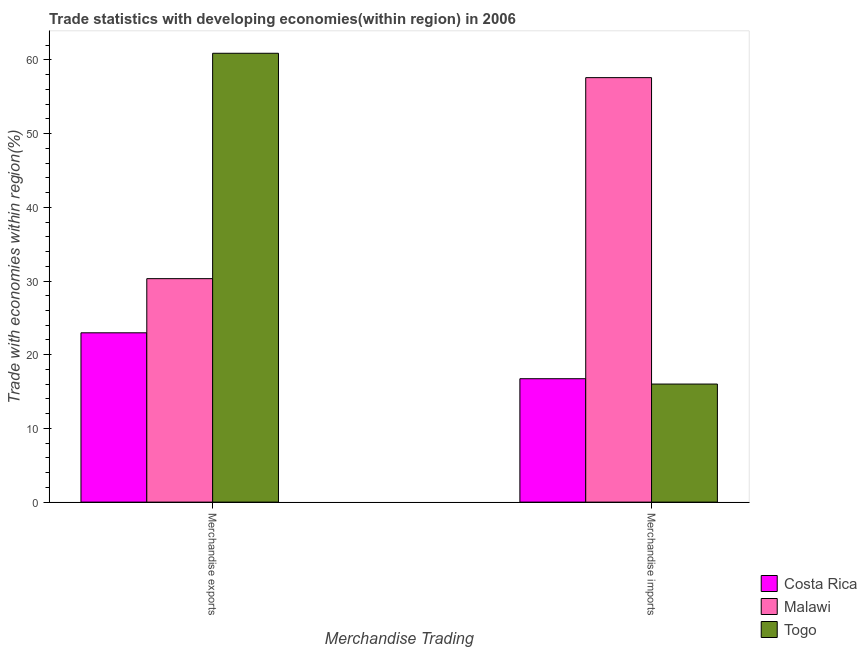How many different coloured bars are there?
Provide a succinct answer. 3. Are the number of bars on each tick of the X-axis equal?
Provide a succinct answer. Yes. What is the label of the 1st group of bars from the left?
Offer a very short reply. Merchandise exports. What is the merchandise imports in Malawi?
Your response must be concise. 57.6. Across all countries, what is the maximum merchandise imports?
Your response must be concise. 57.6. Across all countries, what is the minimum merchandise exports?
Provide a short and direct response. 22.98. In which country was the merchandise imports maximum?
Your response must be concise. Malawi. What is the total merchandise exports in the graph?
Offer a very short reply. 114.21. What is the difference between the merchandise imports in Togo and that in Malawi?
Make the answer very short. -41.58. What is the difference between the merchandise exports in Togo and the merchandise imports in Malawi?
Ensure brevity in your answer.  3.31. What is the average merchandise exports per country?
Your answer should be compact. 38.07. What is the difference between the merchandise exports and merchandise imports in Togo?
Give a very brief answer. 44.89. In how many countries, is the merchandise imports greater than 52 %?
Your answer should be very brief. 1. What is the ratio of the merchandise exports in Malawi to that in Costa Rica?
Provide a short and direct response. 1.32. In how many countries, is the merchandise imports greater than the average merchandise imports taken over all countries?
Keep it short and to the point. 1. What does the 2nd bar from the left in Merchandise imports represents?
Provide a succinct answer. Malawi. What does the 3rd bar from the right in Merchandise exports represents?
Give a very brief answer. Costa Rica. How many bars are there?
Make the answer very short. 6. Are all the bars in the graph horizontal?
Your answer should be very brief. No. How many countries are there in the graph?
Your answer should be compact. 3. What is the difference between two consecutive major ticks on the Y-axis?
Provide a succinct answer. 10. Where does the legend appear in the graph?
Ensure brevity in your answer.  Bottom right. How many legend labels are there?
Your answer should be very brief. 3. How are the legend labels stacked?
Your answer should be compact. Vertical. What is the title of the graph?
Offer a terse response. Trade statistics with developing economies(within region) in 2006. What is the label or title of the X-axis?
Offer a terse response. Merchandise Trading. What is the label or title of the Y-axis?
Provide a succinct answer. Trade with economies within region(%). What is the Trade with economies within region(%) of Costa Rica in Merchandise exports?
Offer a very short reply. 22.98. What is the Trade with economies within region(%) in Malawi in Merchandise exports?
Your response must be concise. 30.32. What is the Trade with economies within region(%) of Togo in Merchandise exports?
Keep it short and to the point. 60.91. What is the Trade with economies within region(%) in Costa Rica in Merchandise imports?
Give a very brief answer. 16.75. What is the Trade with economies within region(%) in Malawi in Merchandise imports?
Offer a terse response. 57.6. What is the Trade with economies within region(%) in Togo in Merchandise imports?
Offer a terse response. 16.02. Across all Merchandise Trading, what is the maximum Trade with economies within region(%) in Costa Rica?
Make the answer very short. 22.98. Across all Merchandise Trading, what is the maximum Trade with economies within region(%) of Malawi?
Ensure brevity in your answer.  57.6. Across all Merchandise Trading, what is the maximum Trade with economies within region(%) in Togo?
Make the answer very short. 60.91. Across all Merchandise Trading, what is the minimum Trade with economies within region(%) in Costa Rica?
Keep it short and to the point. 16.75. Across all Merchandise Trading, what is the minimum Trade with economies within region(%) in Malawi?
Make the answer very short. 30.32. Across all Merchandise Trading, what is the minimum Trade with economies within region(%) of Togo?
Your response must be concise. 16.02. What is the total Trade with economies within region(%) in Costa Rica in the graph?
Offer a terse response. 39.72. What is the total Trade with economies within region(%) of Malawi in the graph?
Ensure brevity in your answer.  87.93. What is the total Trade with economies within region(%) in Togo in the graph?
Give a very brief answer. 76.93. What is the difference between the Trade with economies within region(%) in Costa Rica in Merchandise exports and that in Merchandise imports?
Provide a short and direct response. 6.23. What is the difference between the Trade with economies within region(%) of Malawi in Merchandise exports and that in Merchandise imports?
Keep it short and to the point. -27.28. What is the difference between the Trade with economies within region(%) in Togo in Merchandise exports and that in Merchandise imports?
Make the answer very short. 44.89. What is the difference between the Trade with economies within region(%) of Costa Rica in Merchandise exports and the Trade with economies within region(%) of Malawi in Merchandise imports?
Your answer should be compact. -34.63. What is the difference between the Trade with economies within region(%) in Costa Rica in Merchandise exports and the Trade with economies within region(%) in Togo in Merchandise imports?
Your response must be concise. 6.95. What is the difference between the Trade with economies within region(%) of Malawi in Merchandise exports and the Trade with economies within region(%) of Togo in Merchandise imports?
Your response must be concise. 14.3. What is the average Trade with economies within region(%) of Costa Rica per Merchandise Trading?
Make the answer very short. 19.86. What is the average Trade with economies within region(%) in Malawi per Merchandise Trading?
Provide a succinct answer. 43.96. What is the average Trade with economies within region(%) of Togo per Merchandise Trading?
Keep it short and to the point. 38.47. What is the difference between the Trade with economies within region(%) of Costa Rica and Trade with economies within region(%) of Malawi in Merchandise exports?
Provide a succinct answer. -7.35. What is the difference between the Trade with economies within region(%) of Costa Rica and Trade with economies within region(%) of Togo in Merchandise exports?
Provide a short and direct response. -37.93. What is the difference between the Trade with economies within region(%) of Malawi and Trade with economies within region(%) of Togo in Merchandise exports?
Your response must be concise. -30.58. What is the difference between the Trade with economies within region(%) of Costa Rica and Trade with economies within region(%) of Malawi in Merchandise imports?
Your response must be concise. -40.85. What is the difference between the Trade with economies within region(%) in Costa Rica and Trade with economies within region(%) in Togo in Merchandise imports?
Provide a succinct answer. 0.72. What is the difference between the Trade with economies within region(%) in Malawi and Trade with economies within region(%) in Togo in Merchandise imports?
Offer a very short reply. 41.58. What is the ratio of the Trade with economies within region(%) in Costa Rica in Merchandise exports to that in Merchandise imports?
Your response must be concise. 1.37. What is the ratio of the Trade with economies within region(%) in Malawi in Merchandise exports to that in Merchandise imports?
Offer a very short reply. 0.53. What is the ratio of the Trade with economies within region(%) in Togo in Merchandise exports to that in Merchandise imports?
Give a very brief answer. 3.8. What is the difference between the highest and the second highest Trade with economies within region(%) in Costa Rica?
Your answer should be compact. 6.23. What is the difference between the highest and the second highest Trade with economies within region(%) of Malawi?
Provide a succinct answer. 27.28. What is the difference between the highest and the second highest Trade with economies within region(%) of Togo?
Provide a short and direct response. 44.89. What is the difference between the highest and the lowest Trade with economies within region(%) in Costa Rica?
Provide a short and direct response. 6.23. What is the difference between the highest and the lowest Trade with economies within region(%) of Malawi?
Make the answer very short. 27.28. What is the difference between the highest and the lowest Trade with economies within region(%) of Togo?
Offer a terse response. 44.89. 